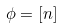Convert formula to latex. <formula><loc_0><loc_0><loc_500><loc_500>\phi = [ n ]</formula> 